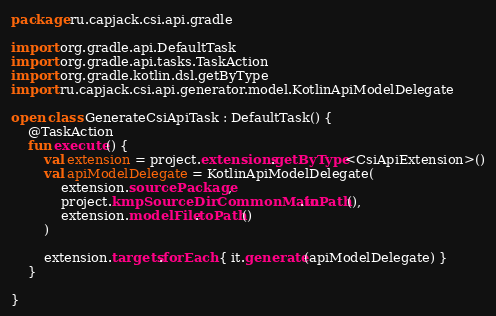<code> <loc_0><loc_0><loc_500><loc_500><_Kotlin_>package ru.capjack.csi.api.gradle

import org.gradle.api.DefaultTask
import org.gradle.api.tasks.TaskAction
import org.gradle.kotlin.dsl.getByType
import ru.capjack.csi.api.generator.model.KotlinApiModelDelegate

open class GenerateCsiApiTask : DefaultTask() {
	@TaskAction
	fun execute() {
		val extension = project.extensions.getByType<CsiApiExtension>()
		val apiModelDelegate = KotlinApiModelDelegate(
			extension.sourcePackage,
			project.kmpSourceDirCommonMain.toPath(),
			extension.modelFile.toPath()
		)
		
		extension.targets.forEach { it.generate(apiModelDelegate) }
	}
	
}

</code> 